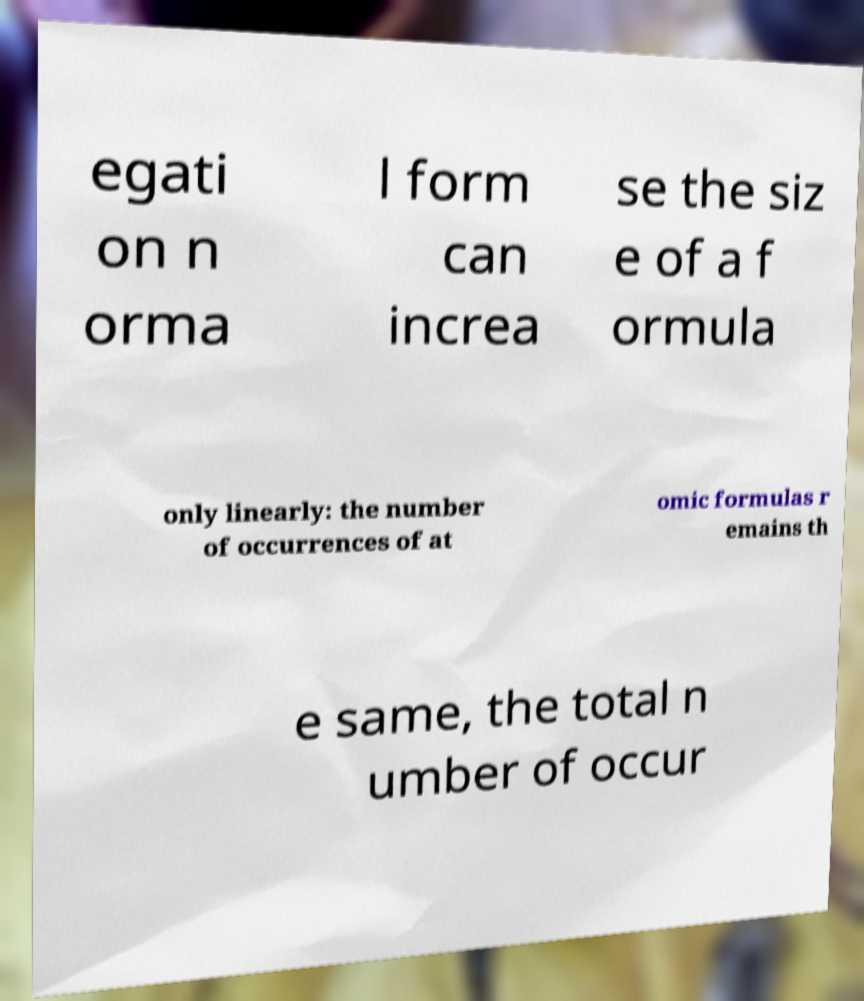There's text embedded in this image that I need extracted. Can you transcribe it verbatim? egati on n orma l form can increa se the siz e of a f ormula only linearly: the number of occurrences of at omic formulas r emains th e same, the total n umber of occur 